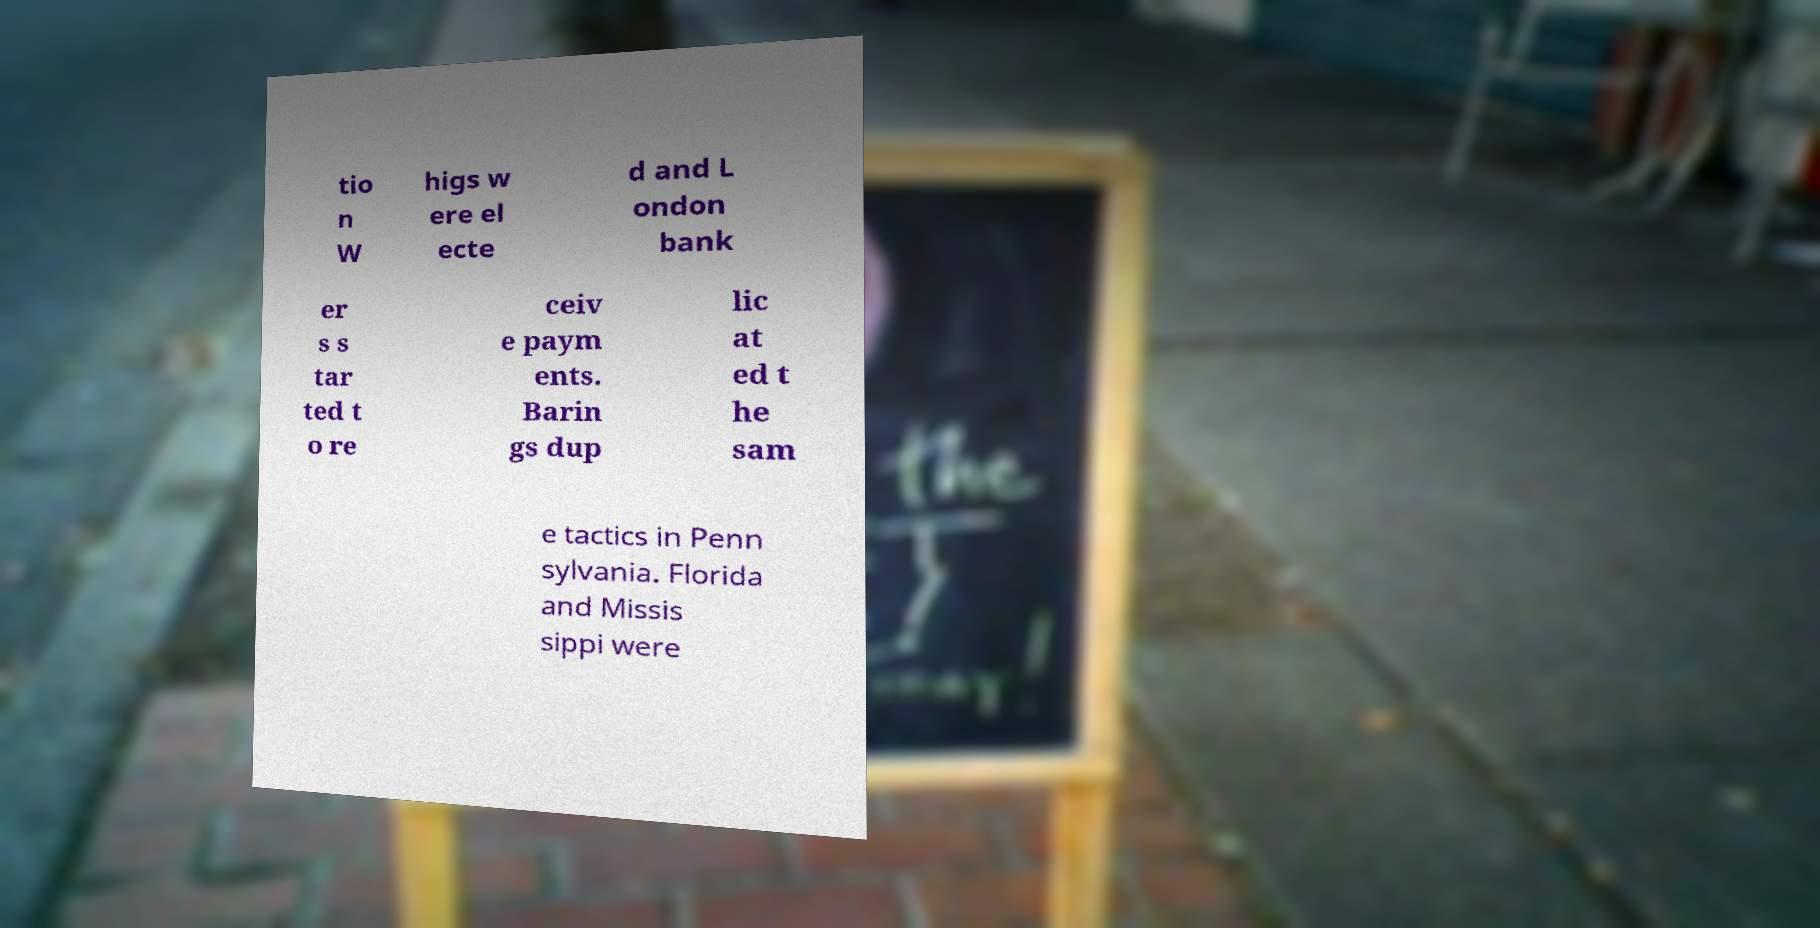Please read and relay the text visible in this image. What does it say? tio n W higs w ere el ecte d and L ondon bank er s s tar ted t o re ceiv e paym ents. Barin gs dup lic at ed t he sam e tactics in Penn sylvania. Florida and Missis sippi were 